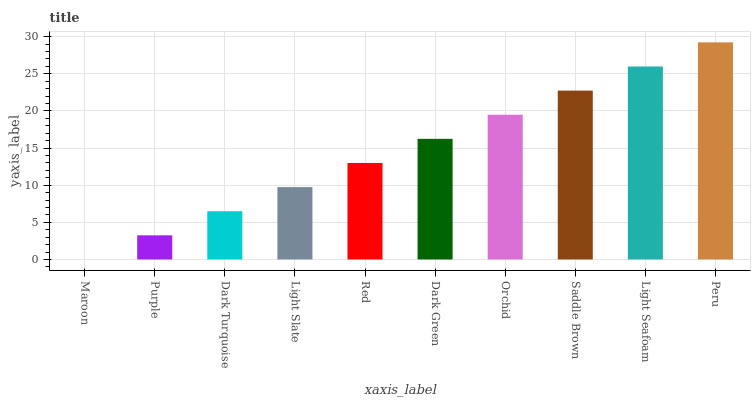Is Maroon the minimum?
Answer yes or no. Yes. Is Peru the maximum?
Answer yes or no. Yes. Is Purple the minimum?
Answer yes or no. No. Is Purple the maximum?
Answer yes or no. No. Is Purple greater than Maroon?
Answer yes or no. Yes. Is Maroon less than Purple?
Answer yes or no. Yes. Is Maroon greater than Purple?
Answer yes or no. No. Is Purple less than Maroon?
Answer yes or no. No. Is Dark Green the high median?
Answer yes or no. Yes. Is Red the low median?
Answer yes or no. Yes. Is Red the high median?
Answer yes or no. No. Is Maroon the low median?
Answer yes or no. No. 